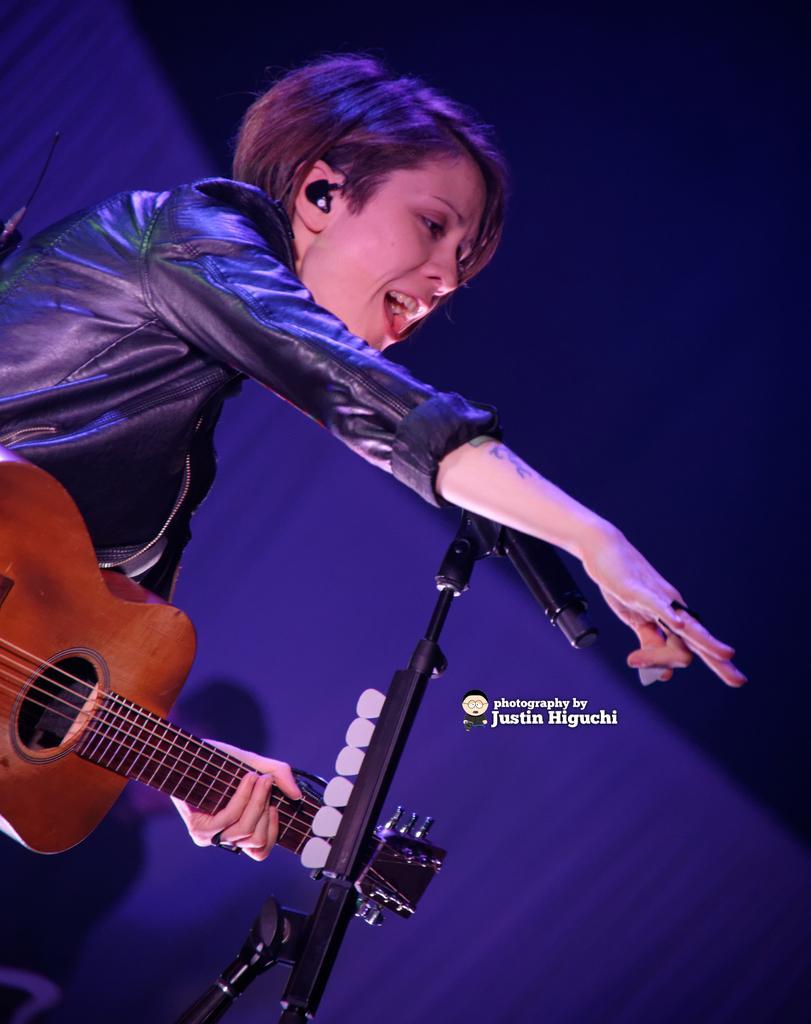Can you describe this image briefly? This image consist of a woman singing and playing guitar. In front of her, there is a mic along with mic stand. The background is blue in color. She is wearing a black jacket. 